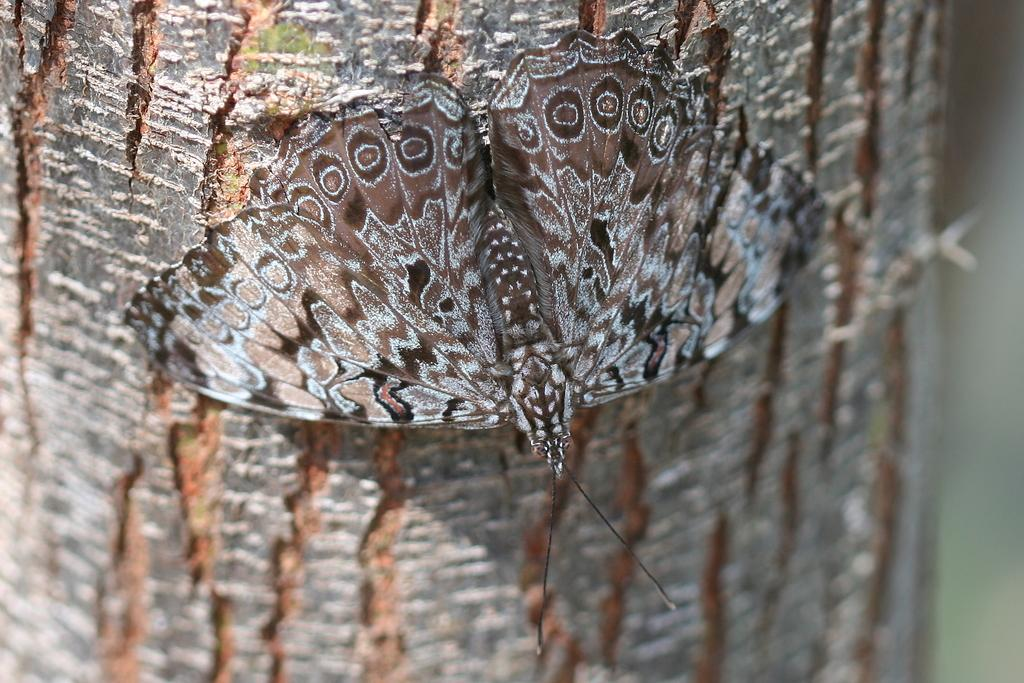What is the main subject of the image? There is a butterfly in the image. Where is the butterfly located? The butterfly is on the bark of a tree. Why is the boy crying in the image? There is no boy present in the image, and therefore no crying can be observed. 